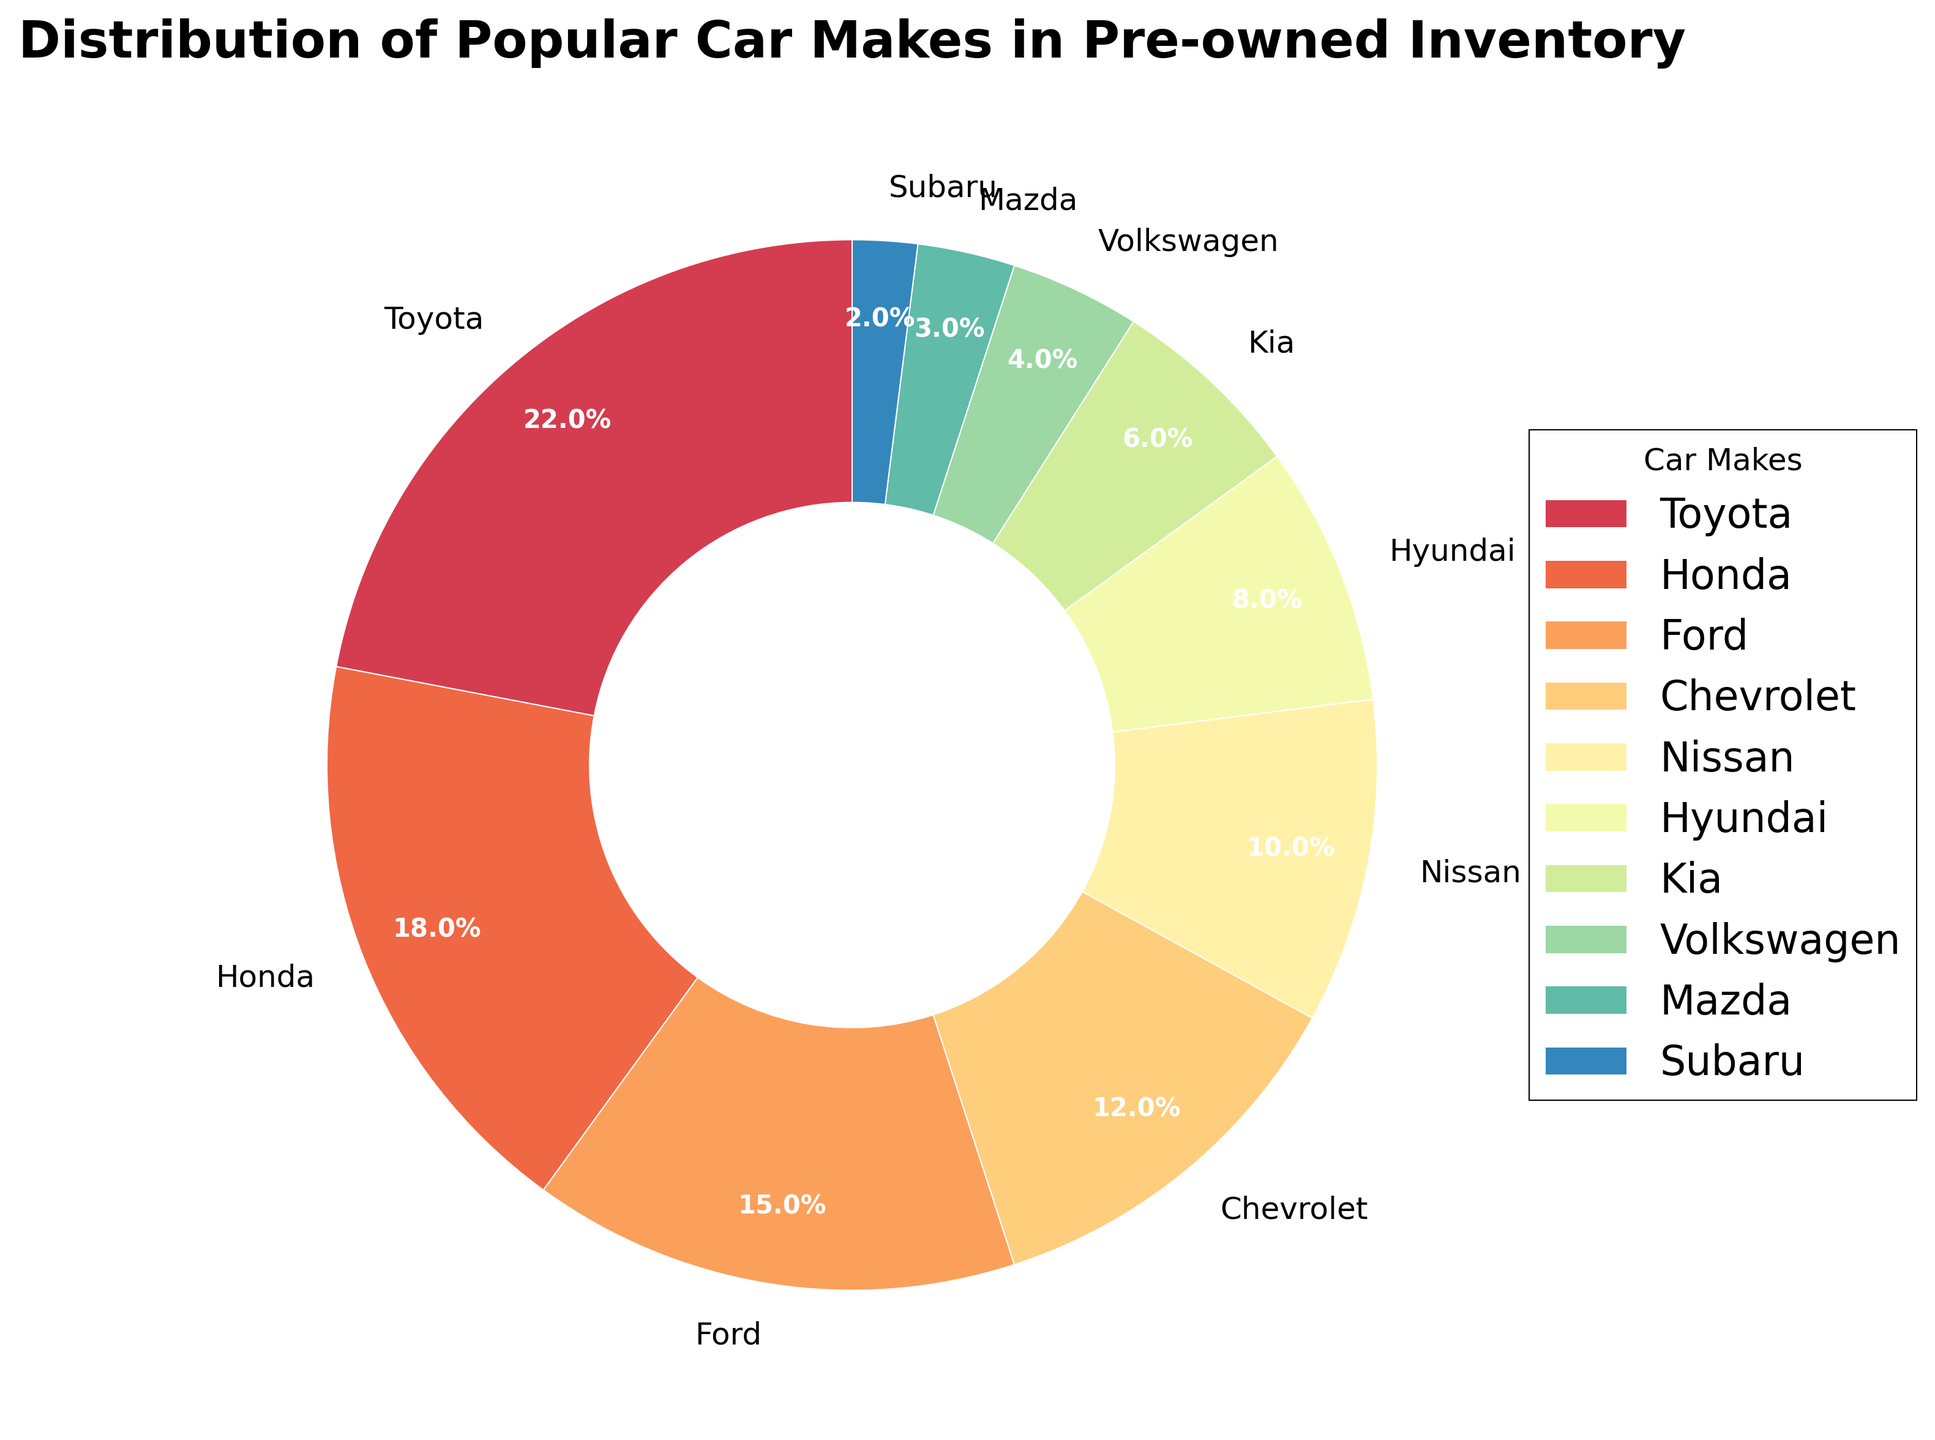What percentage of the inventory is made up of Japanese car makes (Toyota, Honda, and Nissan)? We need to add the percentages of the Japanese car makes listed: Toyota (22%), Honda (18%), and Nissan (10%). Calculating 22 + 18 + 10 gives us 50.
Answer: 50% What is the combined percentage of the least popular car makes (Volkswagen, Mazda, and Subaru)? We add the percentages of the least popular car makes: Volkswagen (4%), Mazda (3%), and Subaru (2%). Calculating 4 + 3 + 2 gives us 9.
Answer: 9% Which car make has the largest share in the pie chart and by how much? The car make with the largest share is Toyota with 22%, as seen in the chart.
Answer: Toyota, 22% How much more popular is Ford compared to Subaru? To find how much more popular Ford is compared to Subaru, we subtract Subaru's percentage (2%) from Ford's percentage (15%). Calculating 15 - 2 gives us 13.
Answer: 13% What are the colors used for Toyota and Hyundai in the pie chart? Based on the color gradient used in a pie chart, Toyota is likely represented by a warm color such as red or orange (largest segment), and Hyundai, being smaller, would be further down the color spectrum likely a cooler color such as light green or blue.
Answer: Toyota: warm color (red/orange), Hyundai: cool color (green/blue) Are there more American car makes (Ford, Chevrolet) in the inventory compared to Korean car makes (Hyundai, Kia)? Adding the percentages of American car makes, we get Ford (15%) + Chevrolet (12%) = 27%. For Korean car makes, adding Hyundai (8%) + Kia (6%) = 14%. Since 27% (American) is greater than 14% (Korean), there are more American car makes.
Answer: Yes Which car make represents the smallest share, and what percentage is it? The smallest share is represented by Subaru at 2%.
Answer: Subaru, 2% What is the percentage difference between the most popular and the least popular car makes? The most popular car make is Toyota (22%) and the least popular is Subaru (2%). Calculating the difference, 22 - 2 gives us 20.
Answer: 20% How do the combined percentages of Ford and Chevrolet compare to the percentage of Toyota? The combined percentages of Ford (15%) and Chevrolet (12%) is 27%. This is 5% greater than Toyota's 22%.
Answer: 5% greater 